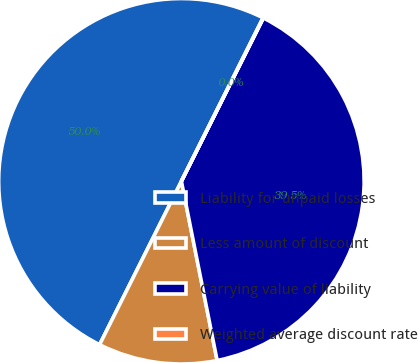<chart> <loc_0><loc_0><loc_500><loc_500><pie_chart><fcel>Liability for unpaid losses<fcel>Less amount of discount<fcel>Carrying value of liability<fcel>Weighted average discount rate<nl><fcel>49.98%<fcel>10.52%<fcel>39.46%<fcel>0.03%<nl></chart> 